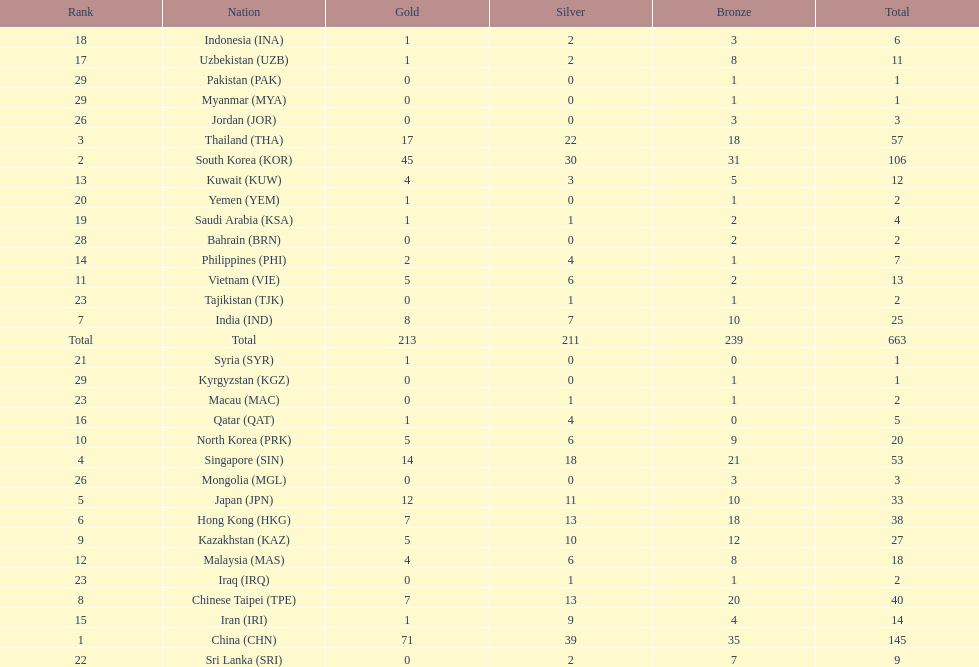Which nation has more gold medals, kuwait or india? India (IND). Parse the full table. {'header': ['Rank', 'Nation', 'Gold', 'Silver', 'Bronze', 'Total'], 'rows': [['18', 'Indonesia\xa0(INA)', '1', '2', '3', '6'], ['17', 'Uzbekistan\xa0(UZB)', '1', '2', '8', '11'], ['29', 'Pakistan\xa0(PAK)', '0', '0', '1', '1'], ['29', 'Myanmar\xa0(MYA)', '0', '0', '1', '1'], ['26', 'Jordan\xa0(JOR)', '0', '0', '3', '3'], ['3', 'Thailand\xa0(THA)', '17', '22', '18', '57'], ['2', 'South Korea\xa0(KOR)', '45', '30', '31', '106'], ['13', 'Kuwait\xa0(KUW)', '4', '3', '5', '12'], ['20', 'Yemen\xa0(YEM)', '1', '0', '1', '2'], ['19', 'Saudi Arabia\xa0(KSA)', '1', '1', '2', '4'], ['28', 'Bahrain\xa0(BRN)', '0', '0', '2', '2'], ['14', 'Philippines\xa0(PHI)', '2', '4', '1', '7'], ['11', 'Vietnam\xa0(VIE)', '5', '6', '2', '13'], ['23', 'Tajikistan\xa0(TJK)', '0', '1', '1', '2'], ['7', 'India\xa0(IND)', '8', '7', '10', '25'], ['Total', 'Total', '213', '211', '239', '663'], ['21', 'Syria\xa0(SYR)', '1', '0', '0', '1'], ['29', 'Kyrgyzstan\xa0(KGZ)', '0', '0', '1', '1'], ['23', 'Macau\xa0(MAC)', '0', '1', '1', '2'], ['16', 'Qatar\xa0(QAT)', '1', '4', '0', '5'], ['10', 'North Korea\xa0(PRK)', '5', '6', '9', '20'], ['4', 'Singapore\xa0(SIN)', '14', '18', '21', '53'], ['26', 'Mongolia\xa0(MGL)', '0', '0', '3', '3'], ['5', 'Japan\xa0(JPN)', '12', '11', '10', '33'], ['6', 'Hong Kong\xa0(HKG)', '7', '13', '18', '38'], ['9', 'Kazakhstan\xa0(KAZ)', '5', '10', '12', '27'], ['12', 'Malaysia\xa0(MAS)', '4', '6', '8', '18'], ['23', 'Iraq\xa0(IRQ)', '0', '1', '1', '2'], ['8', 'Chinese Taipei\xa0(TPE)', '7', '13', '20', '40'], ['15', 'Iran\xa0(IRI)', '1', '9', '4', '14'], ['1', 'China\xa0(CHN)', '71', '39', '35', '145'], ['22', 'Sri Lanka\xa0(SRI)', '0', '2', '7', '9']]} 